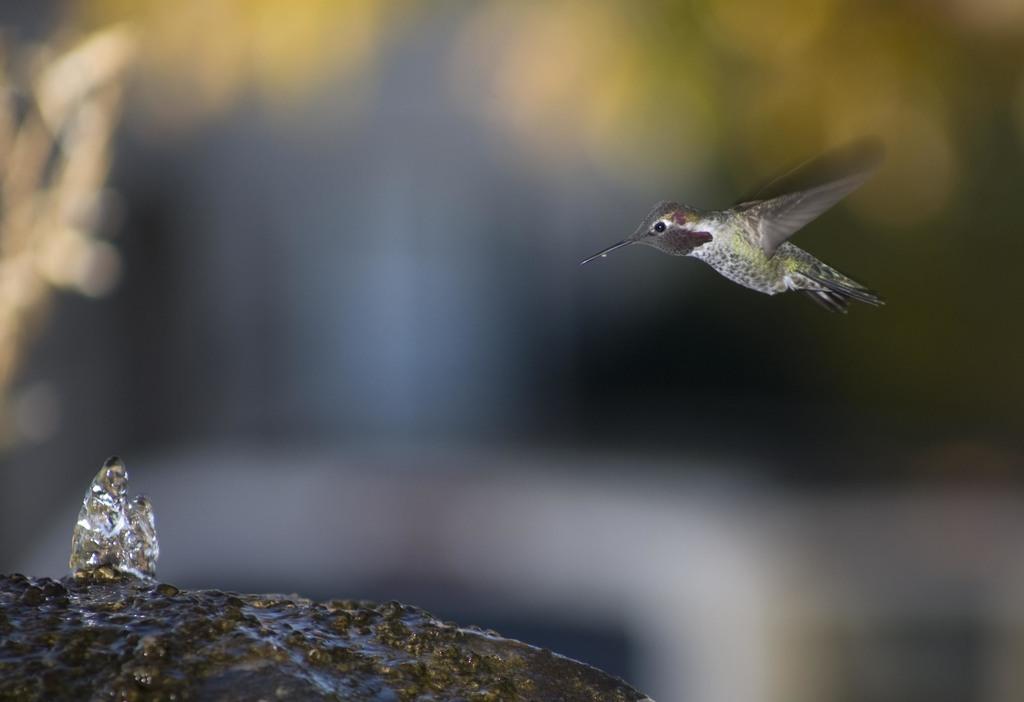How would you summarize this image in a sentence or two? In the picture there is a bird flying towards a stone and the background of the bird is blue. 